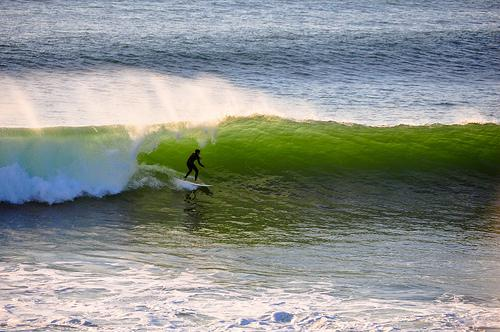Question: what is the man on?
Choices:
A. Surfboard.
B. Skateboard.
C. Skiis.
D. Snowboard.
Answer with the letter. Answer: A Question: who is present?
Choices:
A. Woman.
B. Man.
C. Boy.
D. Girl.
Answer with the letter. Answer: B Question: where is this scene?
Choices:
A. In the sea.
B. In the ocean.
C. In the lake.
D. In the river.
Answer with the letter. Answer: B Question: how is the water?
Choices:
A. Calm.
B. Serene.
C. Wavy.
D. Peaceful.
Answer with the letter. Answer: C Question: when is this?
Choices:
A. Daytime.
B. Night.
C. Dawn.
D. Dusk.
Answer with the letter. Answer: A 